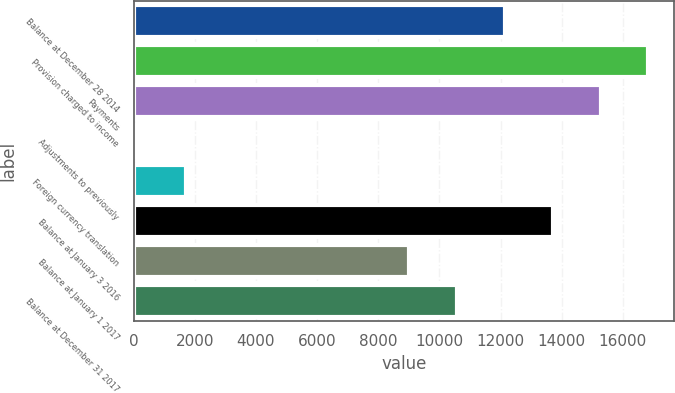Convert chart. <chart><loc_0><loc_0><loc_500><loc_500><bar_chart><fcel>Balance at December 28 2014<fcel>Provision charged to income<fcel>Payments<fcel>Adjustments to previously<fcel>Foreign currency translation<fcel>Balance at January 3 2016<fcel>Balance at January 1 2017<fcel>Balance at December 31 2017<nl><fcel>12141.2<fcel>16835<fcel>15270.4<fcel>146<fcel>1710.6<fcel>13705.8<fcel>9012<fcel>10576.6<nl></chart> 